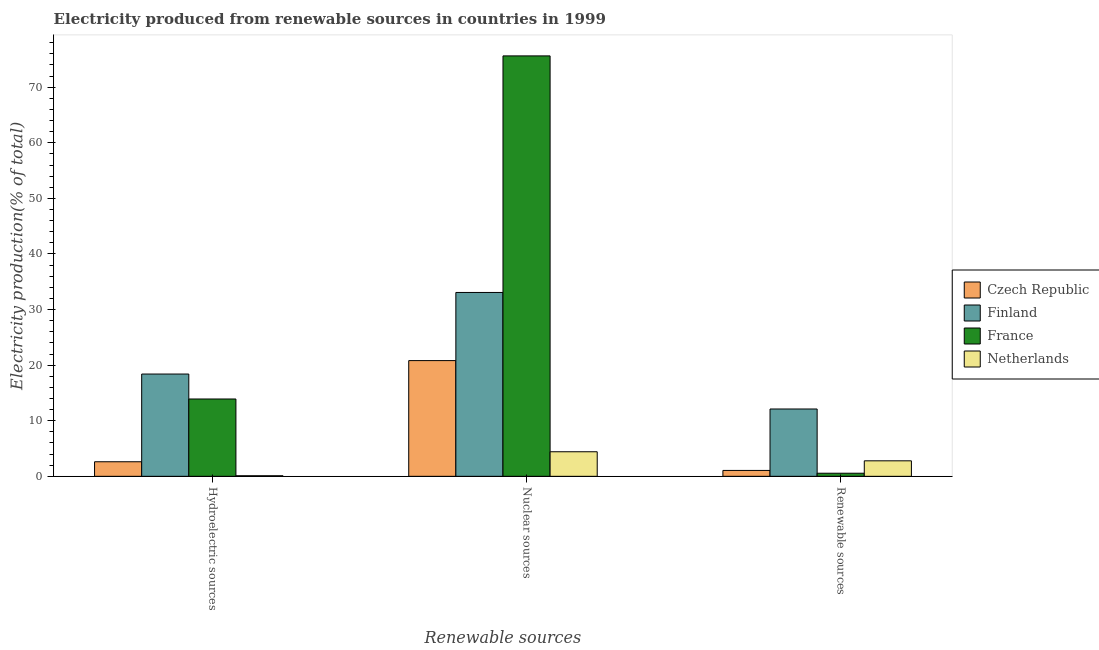How many bars are there on the 3rd tick from the left?
Your answer should be compact. 4. What is the label of the 1st group of bars from the left?
Keep it short and to the point. Hydroelectric sources. What is the percentage of electricity produced by nuclear sources in Netherlands?
Provide a succinct answer. 4.42. Across all countries, what is the maximum percentage of electricity produced by hydroelectric sources?
Provide a succinct answer. 18.4. Across all countries, what is the minimum percentage of electricity produced by hydroelectric sources?
Your response must be concise. 0.1. In which country was the percentage of electricity produced by renewable sources maximum?
Your answer should be compact. Finland. What is the total percentage of electricity produced by nuclear sources in the graph?
Keep it short and to the point. 133.95. What is the difference between the percentage of electricity produced by hydroelectric sources in France and that in Czech Republic?
Make the answer very short. 11.29. What is the difference between the percentage of electricity produced by hydroelectric sources in Netherlands and the percentage of electricity produced by renewable sources in Czech Republic?
Offer a terse response. -0.95. What is the average percentage of electricity produced by renewable sources per country?
Offer a terse response. 4.13. What is the difference between the percentage of electricity produced by nuclear sources and percentage of electricity produced by renewable sources in Czech Republic?
Offer a terse response. 19.76. What is the ratio of the percentage of electricity produced by renewable sources in Netherlands to that in Finland?
Your answer should be very brief. 0.23. Is the difference between the percentage of electricity produced by nuclear sources in Czech Republic and France greater than the difference between the percentage of electricity produced by hydroelectric sources in Czech Republic and France?
Provide a short and direct response. No. What is the difference between the highest and the second highest percentage of electricity produced by renewable sources?
Make the answer very short. 9.33. What is the difference between the highest and the lowest percentage of electricity produced by nuclear sources?
Ensure brevity in your answer.  71.22. In how many countries, is the percentage of electricity produced by renewable sources greater than the average percentage of electricity produced by renewable sources taken over all countries?
Make the answer very short. 1. What does the 1st bar from the left in Hydroelectric sources represents?
Provide a short and direct response. Czech Republic. What does the 4th bar from the right in Renewable sources represents?
Offer a very short reply. Czech Republic. How many bars are there?
Your answer should be compact. 12. Are all the bars in the graph horizontal?
Ensure brevity in your answer.  No. Where does the legend appear in the graph?
Give a very brief answer. Center right. How many legend labels are there?
Your answer should be very brief. 4. What is the title of the graph?
Give a very brief answer. Electricity produced from renewable sources in countries in 1999. Does "Palau" appear as one of the legend labels in the graph?
Provide a short and direct response. No. What is the label or title of the X-axis?
Ensure brevity in your answer.  Renewable sources. What is the label or title of the Y-axis?
Provide a succinct answer. Electricity production(% of total). What is the Electricity production(% of total) in Czech Republic in Hydroelectric sources?
Your response must be concise. 2.62. What is the Electricity production(% of total) in Finland in Hydroelectric sources?
Offer a very short reply. 18.4. What is the Electricity production(% of total) in France in Hydroelectric sources?
Your answer should be compact. 13.91. What is the Electricity production(% of total) of Netherlands in Hydroelectric sources?
Your answer should be very brief. 0.1. What is the Electricity production(% of total) in Czech Republic in Nuclear sources?
Provide a succinct answer. 20.82. What is the Electricity production(% of total) in Finland in Nuclear sources?
Provide a succinct answer. 33.08. What is the Electricity production(% of total) of France in Nuclear sources?
Your answer should be very brief. 75.64. What is the Electricity production(% of total) of Netherlands in Nuclear sources?
Make the answer very short. 4.42. What is the Electricity production(% of total) of Czech Republic in Renewable sources?
Offer a very short reply. 1.06. What is the Electricity production(% of total) in Finland in Renewable sources?
Your answer should be very brief. 12.11. What is the Electricity production(% of total) of France in Renewable sources?
Your answer should be compact. 0.55. What is the Electricity production(% of total) of Netherlands in Renewable sources?
Make the answer very short. 2.79. Across all Renewable sources, what is the maximum Electricity production(% of total) in Czech Republic?
Ensure brevity in your answer.  20.82. Across all Renewable sources, what is the maximum Electricity production(% of total) in Finland?
Your response must be concise. 33.08. Across all Renewable sources, what is the maximum Electricity production(% of total) in France?
Offer a terse response. 75.64. Across all Renewable sources, what is the maximum Electricity production(% of total) in Netherlands?
Keep it short and to the point. 4.42. Across all Renewable sources, what is the minimum Electricity production(% of total) in Czech Republic?
Give a very brief answer. 1.06. Across all Renewable sources, what is the minimum Electricity production(% of total) of Finland?
Make the answer very short. 12.11. Across all Renewable sources, what is the minimum Electricity production(% of total) in France?
Your answer should be compact. 0.55. Across all Renewable sources, what is the minimum Electricity production(% of total) in Netherlands?
Offer a very short reply. 0.1. What is the total Electricity production(% of total) in Czech Republic in the graph?
Your response must be concise. 24.5. What is the total Electricity production(% of total) of Finland in the graph?
Your answer should be very brief. 63.59. What is the total Electricity production(% of total) of France in the graph?
Provide a succinct answer. 90.1. What is the total Electricity production(% of total) in Netherlands in the graph?
Your answer should be very brief. 7.31. What is the difference between the Electricity production(% of total) in Czech Republic in Hydroelectric sources and that in Nuclear sources?
Your response must be concise. -18.2. What is the difference between the Electricity production(% of total) of Finland in Hydroelectric sources and that in Nuclear sources?
Ensure brevity in your answer.  -14.68. What is the difference between the Electricity production(% of total) of France in Hydroelectric sources and that in Nuclear sources?
Your response must be concise. -61.72. What is the difference between the Electricity production(% of total) of Netherlands in Hydroelectric sources and that in Nuclear sources?
Your answer should be compact. -4.32. What is the difference between the Electricity production(% of total) of Czech Republic in Hydroelectric sources and that in Renewable sources?
Keep it short and to the point. 1.56. What is the difference between the Electricity production(% of total) of Finland in Hydroelectric sources and that in Renewable sources?
Your answer should be compact. 6.29. What is the difference between the Electricity production(% of total) of France in Hydroelectric sources and that in Renewable sources?
Make the answer very short. 13.36. What is the difference between the Electricity production(% of total) of Netherlands in Hydroelectric sources and that in Renewable sources?
Ensure brevity in your answer.  -2.68. What is the difference between the Electricity production(% of total) of Czech Republic in Nuclear sources and that in Renewable sources?
Offer a very short reply. 19.76. What is the difference between the Electricity production(% of total) of Finland in Nuclear sources and that in Renewable sources?
Offer a terse response. 20.96. What is the difference between the Electricity production(% of total) of France in Nuclear sources and that in Renewable sources?
Offer a very short reply. 75.08. What is the difference between the Electricity production(% of total) of Netherlands in Nuclear sources and that in Renewable sources?
Offer a very short reply. 1.63. What is the difference between the Electricity production(% of total) of Czech Republic in Hydroelectric sources and the Electricity production(% of total) of Finland in Nuclear sources?
Ensure brevity in your answer.  -30.46. What is the difference between the Electricity production(% of total) of Czech Republic in Hydroelectric sources and the Electricity production(% of total) of France in Nuclear sources?
Give a very brief answer. -73.02. What is the difference between the Electricity production(% of total) in Czech Republic in Hydroelectric sources and the Electricity production(% of total) in Netherlands in Nuclear sources?
Ensure brevity in your answer.  -1.8. What is the difference between the Electricity production(% of total) of Finland in Hydroelectric sources and the Electricity production(% of total) of France in Nuclear sources?
Your answer should be very brief. -57.24. What is the difference between the Electricity production(% of total) in Finland in Hydroelectric sources and the Electricity production(% of total) in Netherlands in Nuclear sources?
Ensure brevity in your answer.  13.98. What is the difference between the Electricity production(% of total) in France in Hydroelectric sources and the Electricity production(% of total) in Netherlands in Nuclear sources?
Ensure brevity in your answer.  9.49. What is the difference between the Electricity production(% of total) in Czech Republic in Hydroelectric sources and the Electricity production(% of total) in Finland in Renewable sources?
Give a very brief answer. -9.49. What is the difference between the Electricity production(% of total) in Czech Republic in Hydroelectric sources and the Electricity production(% of total) in France in Renewable sources?
Your answer should be compact. 2.07. What is the difference between the Electricity production(% of total) in Czech Republic in Hydroelectric sources and the Electricity production(% of total) in Netherlands in Renewable sources?
Offer a very short reply. -0.17. What is the difference between the Electricity production(% of total) in Finland in Hydroelectric sources and the Electricity production(% of total) in France in Renewable sources?
Provide a succinct answer. 17.84. What is the difference between the Electricity production(% of total) of Finland in Hydroelectric sources and the Electricity production(% of total) of Netherlands in Renewable sources?
Offer a terse response. 15.61. What is the difference between the Electricity production(% of total) of France in Hydroelectric sources and the Electricity production(% of total) of Netherlands in Renewable sources?
Provide a succinct answer. 11.12. What is the difference between the Electricity production(% of total) of Czech Republic in Nuclear sources and the Electricity production(% of total) of Finland in Renewable sources?
Offer a terse response. 8.71. What is the difference between the Electricity production(% of total) in Czech Republic in Nuclear sources and the Electricity production(% of total) in France in Renewable sources?
Keep it short and to the point. 20.26. What is the difference between the Electricity production(% of total) of Czech Republic in Nuclear sources and the Electricity production(% of total) of Netherlands in Renewable sources?
Keep it short and to the point. 18.03. What is the difference between the Electricity production(% of total) in Finland in Nuclear sources and the Electricity production(% of total) in France in Renewable sources?
Keep it short and to the point. 32.52. What is the difference between the Electricity production(% of total) of Finland in Nuclear sources and the Electricity production(% of total) of Netherlands in Renewable sources?
Keep it short and to the point. 30.29. What is the difference between the Electricity production(% of total) in France in Nuclear sources and the Electricity production(% of total) in Netherlands in Renewable sources?
Provide a succinct answer. 72.85. What is the average Electricity production(% of total) of Czech Republic per Renewable sources?
Give a very brief answer. 8.17. What is the average Electricity production(% of total) of Finland per Renewable sources?
Ensure brevity in your answer.  21.2. What is the average Electricity production(% of total) in France per Renewable sources?
Keep it short and to the point. 30.03. What is the average Electricity production(% of total) of Netherlands per Renewable sources?
Provide a succinct answer. 2.44. What is the difference between the Electricity production(% of total) in Czech Republic and Electricity production(% of total) in Finland in Hydroelectric sources?
Make the answer very short. -15.78. What is the difference between the Electricity production(% of total) in Czech Republic and Electricity production(% of total) in France in Hydroelectric sources?
Your response must be concise. -11.29. What is the difference between the Electricity production(% of total) of Czech Republic and Electricity production(% of total) of Netherlands in Hydroelectric sources?
Make the answer very short. 2.52. What is the difference between the Electricity production(% of total) in Finland and Electricity production(% of total) in France in Hydroelectric sources?
Ensure brevity in your answer.  4.49. What is the difference between the Electricity production(% of total) of Finland and Electricity production(% of total) of Netherlands in Hydroelectric sources?
Make the answer very short. 18.3. What is the difference between the Electricity production(% of total) of France and Electricity production(% of total) of Netherlands in Hydroelectric sources?
Make the answer very short. 13.81. What is the difference between the Electricity production(% of total) in Czech Republic and Electricity production(% of total) in Finland in Nuclear sources?
Your answer should be very brief. -12.26. What is the difference between the Electricity production(% of total) in Czech Republic and Electricity production(% of total) in France in Nuclear sources?
Your response must be concise. -54.82. What is the difference between the Electricity production(% of total) of Czech Republic and Electricity production(% of total) of Netherlands in Nuclear sources?
Keep it short and to the point. 16.4. What is the difference between the Electricity production(% of total) of Finland and Electricity production(% of total) of France in Nuclear sources?
Your answer should be compact. -42.56. What is the difference between the Electricity production(% of total) of Finland and Electricity production(% of total) of Netherlands in Nuclear sources?
Offer a terse response. 28.66. What is the difference between the Electricity production(% of total) of France and Electricity production(% of total) of Netherlands in Nuclear sources?
Make the answer very short. 71.22. What is the difference between the Electricity production(% of total) in Czech Republic and Electricity production(% of total) in Finland in Renewable sources?
Provide a succinct answer. -11.05. What is the difference between the Electricity production(% of total) of Czech Republic and Electricity production(% of total) of France in Renewable sources?
Keep it short and to the point. 0.5. What is the difference between the Electricity production(% of total) in Czech Republic and Electricity production(% of total) in Netherlands in Renewable sources?
Keep it short and to the point. -1.73. What is the difference between the Electricity production(% of total) in Finland and Electricity production(% of total) in France in Renewable sources?
Your response must be concise. 11.56. What is the difference between the Electricity production(% of total) in Finland and Electricity production(% of total) in Netherlands in Renewable sources?
Make the answer very short. 9.33. What is the difference between the Electricity production(% of total) in France and Electricity production(% of total) in Netherlands in Renewable sources?
Provide a succinct answer. -2.23. What is the ratio of the Electricity production(% of total) in Czech Republic in Hydroelectric sources to that in Nuclear sources?
Provide a short and direct response. 0.13. What is the ratio of the Electricity production(% of total) of Finland in Hydroelectric sources to that in Nuclear sources?
Your response must be concise. 0.56. What is the ratio of the Electricity production(% of total) in France in Hydroelectric sources to that in Nuclear sources?
Keep it short and to the point. 0.18. What is the ratio of the Electricity production(% of total) of Netherlands in Hydroelectric sources to that in Nuclear sources?
Provide a succinct answer. 0.02. What is the ratio of the Electricity production(% of total) in Czech Republic in Hydroelectric sources to that in Renewable sources?
Ensure brevity in your answer.  2.48. What is the ratio of the Electricity production(% of total) in Finland in Hydroelectric sources to that in Renewable sources?
Your answer should be compact. 1.52. What is the ratio of the Electricity production(% of total) in France in Hydroelectric sources to that in Renewable sources?
Offer a very short reply. 25.07. What is the ratio of the Electricity production(% of total) in Netherlands in Hydroelectric sources to that in Renewable sources?
Ensure brevity in your answer.  0.04. What is the ratio of the Electricity production(% of total) in Czech Republic in Nuclear sources to that in Renewable sources?
Provide a succinct answer. 19.67. What is the ratio of the Electricity production(% of total) of Finland in Nuclear sources to that in Renewable sources?
Provide a short and direct response. 2.73. What is the ratio of the Electricity production(% of total) of France in Nuclear sources to that in Renewable sources?
Keep it short and to the point. 136.32. What is the ratio of the Electricity production(% of total) of Netherlands in Nuclear sources to that in Renewable sources?
Ensure brevity in your answer.  1.59. What is the difference between the highest and the second highest Electricity production(% of total) in Czech Republic?
Offer a very short reply. 18.2. What is the difference between the highest and the second highest Electricity production(% of total) of Finland?
Make the answer very short. 14.68. What is the difference between the highest and the second highest Electricity production(% of total) of France?
Ensure brevity in your answer.  61.72. What is the difference between the highest and the second highest Electricity production(% of total) in Netherlands?
Ensure brevity in your answer.  1.63. What is the difference between the highest and the lowest Electricity production(% of total) in Czech Republic?
Your answer should be very brief. 19.76. What is the difference between the highest and the lowest Electricity production(% of total) of Finland?
Make the answer very short. 20.96. What is the difference between the highest and the lowest Electricity production(% of total) of France?
Provide a short and direct response. 75.08. What is the difference between the highest and the lowest Electricity production(% of total) in Netherlands?
Offer a very short reply. 4.32. 